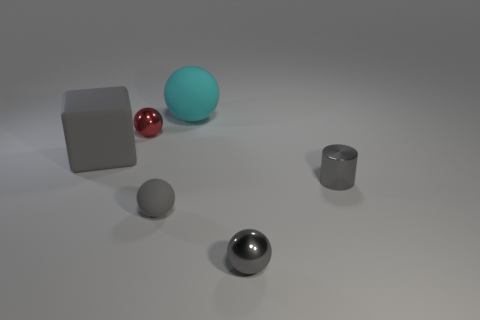There is a small gray metal thing that is in front of the small gray rubber sphere; is its shape the same as the cyan thing?
Ensure brevity in your answer.  Yes. How many gray objects are either big matte balls or tiny rubber objects?
Offer a terse response. 1. Are there the same number of tiny red spheres that are left of the cyan matte sphere and cubes right of the gray cylinder?
Ensure brevity in your answer.  No. What is the color of the metallic ball that is right of the small object that is behind the big matte thing in front of the red object?
Provide a succinct answer. Gray. Is there anything else of the same color as the large ball?
Give a very brief answer. No. What is the shape of the large thing that is the same color as the small cylinder?
Make the answer very short. Cube. There is a matte ball behind the big matte block; how big is it?
Keep it short and to the point. Large. There is a red object that is the same size as the gray metal cylinder; what shape is it?
Your answer should be compact. Sphere. Is the gray thing that is on the right side of the gray shiny ball made of the same material as the gray thing that is behind the gray metallic cylinder?
Offer a terse response. No. What is the material of the large thing in front of the ball to the left of the tiny gray rubber sphere?
Provide a short and direct response. Rubber. 